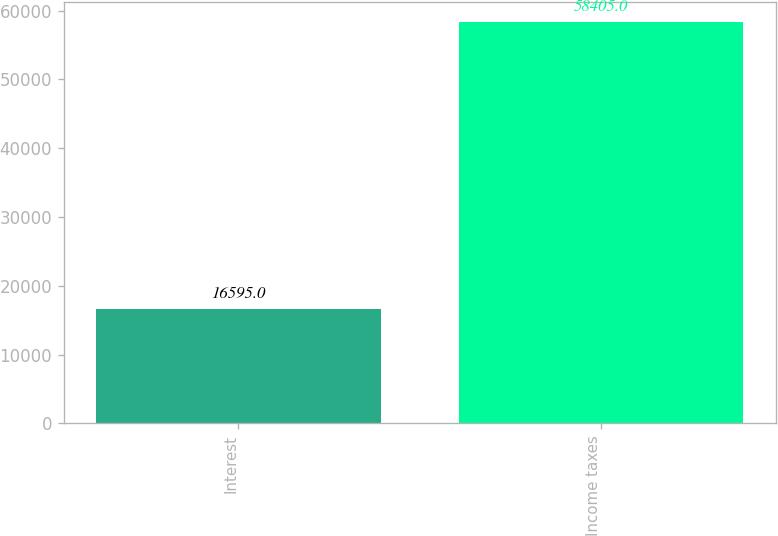Convert chart. <chart><loc_0><loc_0><loc_500><loc_500><bar_chart><fcel>Interest<fcel>Income taxes<nl><fcel>16595<fcel>58405<nl></chart> 